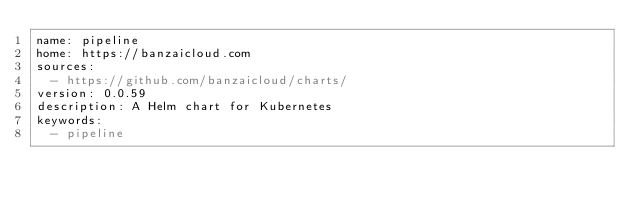Convert code to text. <code><loc_0><loc_0><loc_500><loc_500><_YAML_>name: pipeline
home: https://banzaicloud.com
sources:
  - https://github.com/banzaicloud/charts/
version: 0.0.59
description: A Helm chart for Kubernetes
keywords:
  - pipeline
</code> 